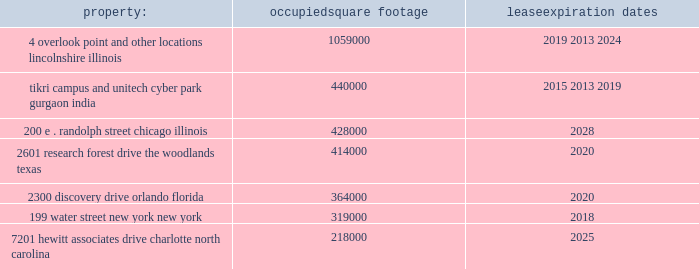Approximately 99% ( 99 % ) of the outstanding shares of common stock of aon corporation were held within the dtc system .
The class a ordinary shares of aon plc are , at present , eligible for deposit and clearing within the dtc system .
In connection with the closing of the redomestication , we entered into arrangements with dtc whereby we agreed to indemnify dtc for any stamp duty and/or sdrt that may be assessed upon it as a result of its service as a depository and clearing agency for our class a ordinary shares .
In addition , we have obtained a ruling from hmrc in respect of the stamp duty and sdrt consequences of the reorganization , and sdrt has been paid in accordance with the terms of this ruling in respect of the deposit of class a ordinary shares with the initial depository .
Dtc will generally have discretion to cease to act as a depository and clearing agency for the class a ordinary shares .
If dtc determines at any time that the class a ordinary shares are not eligible for continued deposit and clearance within its facilities , then we believe the class a ordinary shares would not be eligible for continued listing on a u.s .
Securities exchange or inclusion in the s&p 500 and trading in the class a ordinary shares would be disrupted .
While we would pursue alternative arrangements to preserve our listing and maintain trading , any such disruption could have a material adverse effect on the trading price of the class a ordinary shares .
Item 1b .
Unresolved staff comments .
Item 2 .
Properties .
We have offices in various locations throughout the world .
Substantially all of our offices are located in leased premises .
We maintain our corporate headquarters at 122 leadenhall street , london , england , where we occupy approximately 190000 square feet of space under an operating lease agreement that expires in 2034 .
We own one significant building at pallbergweg 2-4 , amsterdam , the netherlands ( 150000 square feet ) .
The following are additional significant leased properties , along with the occupied square footage and expiration .
Property : occupied square footage expiration .
The locations in lincolnshire , illinois , gurgaon , india , the woodlands , texas , orlando , florida , and charlotte , north carolina , are primarily dedicated to our hr solutions segment .
The other locations listed above house personnel from both of our reportable segments .
In general , no difficulty is anticipated in negotiating renewals as leases expire or in finding other satisfactory space if the premises become unavailable .
We believe that the facilities we currently occupy are adequate for the purposes for which they are being used and are well maintained .
In certain circumstances , we may have unused space and may seek to sublet such space to third parties , depending upon the demands for office space in the locations involved .
See note 7 "lease commitments" of the notes to consolidated financial statements in part ii , item 8 of this report for information with respect to our lease commitments as of december 31 , 2015 .
Item 3 .
Legal proceedings .
We hereby incorporate by reference note 14 "commitments and contingencies" of the notes to consolidated financial statements in part ii , item 8 of this report .
Item 4 .
Mine safety disclosure .
Not applicable. .
What is the total square feet of buildings whose lease will expire in 2020? 
Computations: (414000 + 364000)
Answer: 778000.0. 